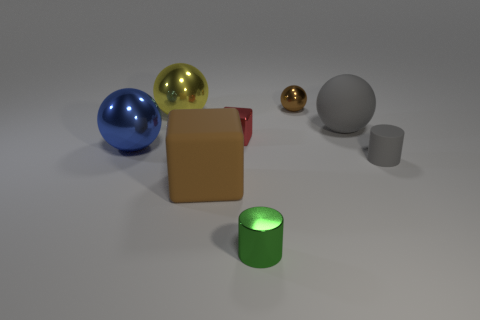What number of objects are small shiny cylinders or large objects that are to the left of the gray matte ball?
Ensure brevity in your answer.  4. Are there fewer tiny red objects than blue metallic cylinders?
Provide a succinct answer. No. What color is the small shiny object behind the yellow ball behind the gray object that is in front of the red block?
Offer a terse response. Brown. Is the tiny green thing made of the same material as the brown block?
Provide a succinct answer. No. There is a gray cylinder; how many gray objects are behind it?
Your answer should be compact. 1. The blue metal object that is the same shape as the large gray thing is what size?
Provide a short and direct response. Large. How many brown objects are either rubber cylinders or large blocks?
Ensure brevity in your answer.  1. There is a ball to the right of the small brown metallic sphere; what number of balls are behind it?
Your answer should be compact. 2. What number of other things are there of the same shape as the large blue shiny object?
Make the answer very short. 3. What material is the small object that is the same color as the rubber cube?
Your response must be concise. Metal. 